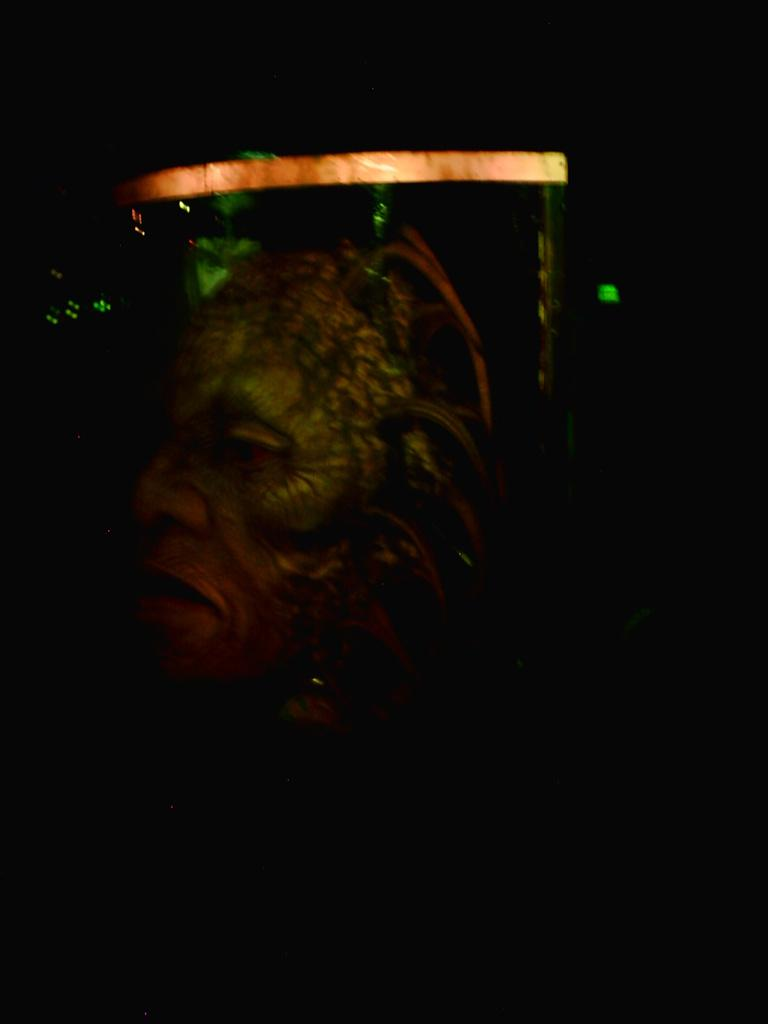What object is the main focus of the image? There is a mask in the image. Can you describe the colors of the mask? The mask is green and orange in color. What does the mask represent? The mask represents a monster. What is the color of the background in the image? The background of the image is black. What type of light can be seen in the image? There is an orange light in the image. What type of skate is being used by the monster in the image? There is no skate present in the image; it only features a mask representing a monster. What emotion does the monster in the image express? The image does not convey any specific emotion, as it only shows a mask representing a monster. 